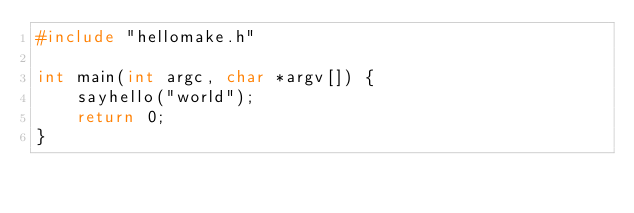<code> <loc_0><loc_0><loc_500><loc_500><_C_>#include "hellomake.h"

int main(int argc, char *argv[]) {
    sayhello("world");
    return 0;
}</code> 